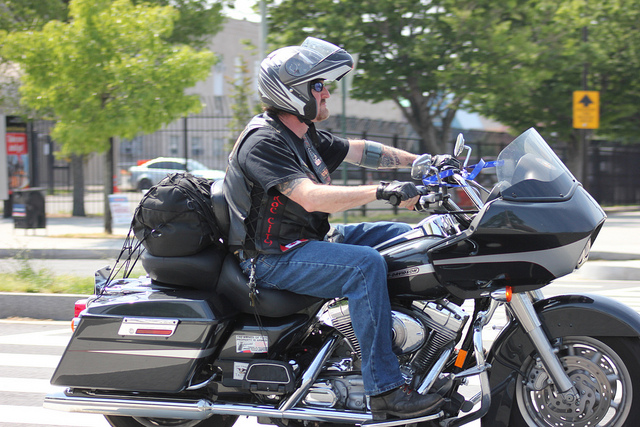What kind of motorcycle is the person riding? The person is riding a touring motorcycle, designed for long-distance riding with features like a large windscreen and ample storage compartments. 